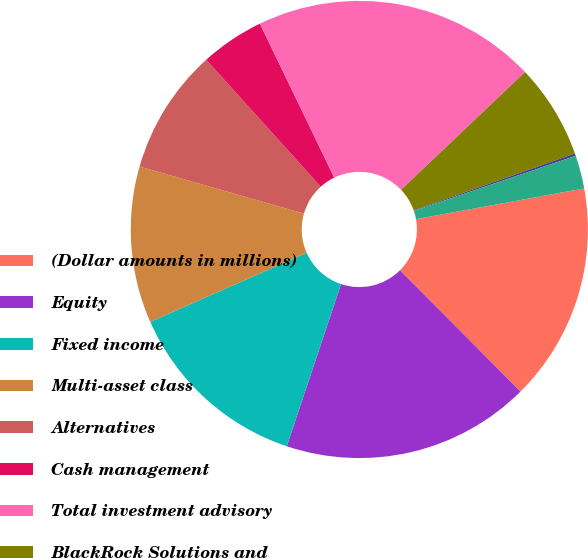Convert chart to OTSL. <chart><loc_0><loc_0><loc_500><loc_500><pie_chart><fcel>(Dollar amounts in millions)<fcel>Equity<fcel>Fixed income<fcel>Multi-asset class<fcel>Alternatives<fcel>Cash management<fcel>Total investment advisory<fcel>BlackRock Solutions and<fcel>Distribution fees<fcel>Other revenue<nl><fcel>15.42%<fcel>17.6%<fcel>13.24%<fcel>11.06%<fcel>8.88%<fcel>4.52%<fcel>20.07%<fcel>6.7%<fcel>0.17%<fcel>2.35%<nl></chart> 